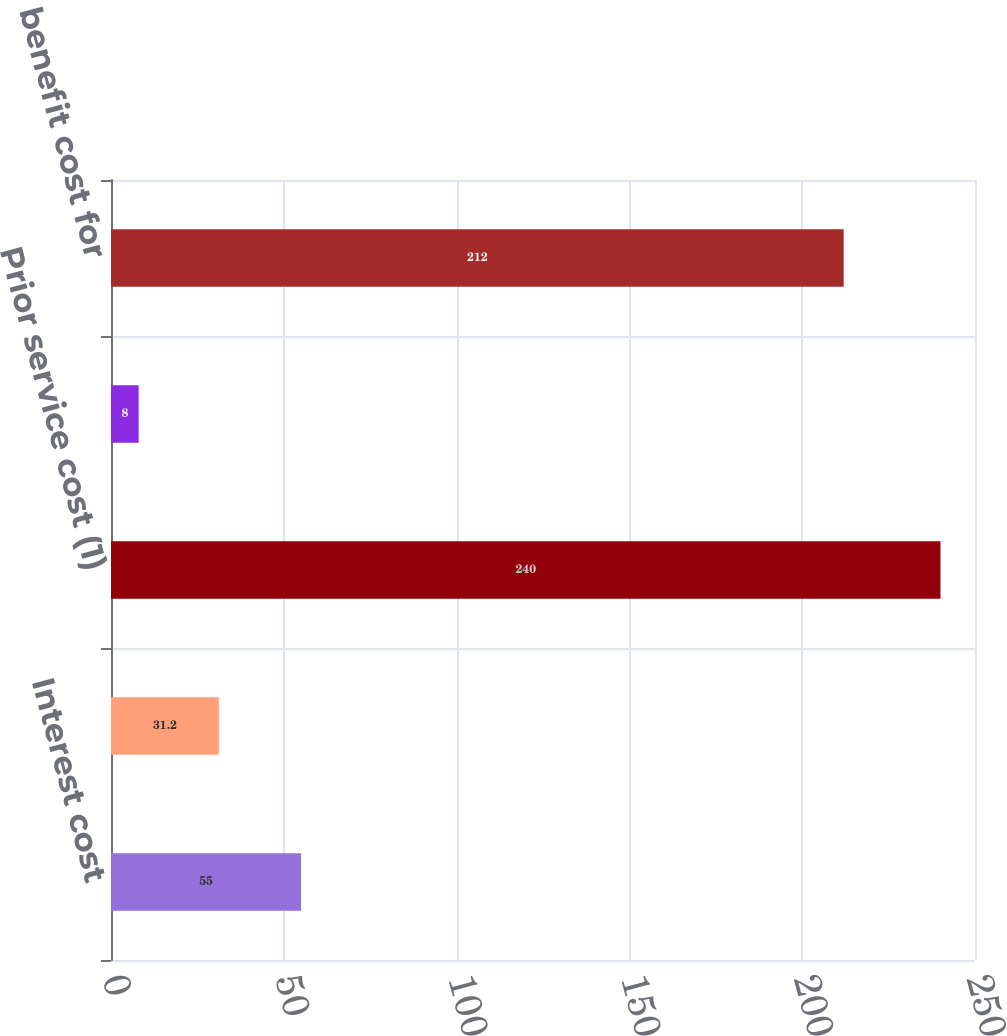Convert chart to OTSL. <chart><loc_0><loc_0><loc_500><loc_500><bar_chart><fcel>Interest cost<fcel>Expected return on assets<fcel>Prior service cost (1)<fcel>Unrecognized net loss (gain)<fcel>Net periodic benefit cost for<nl><fcel>55<fcel>31.2<fcel>240<fcel>8<fcel>212<nl></chart> 